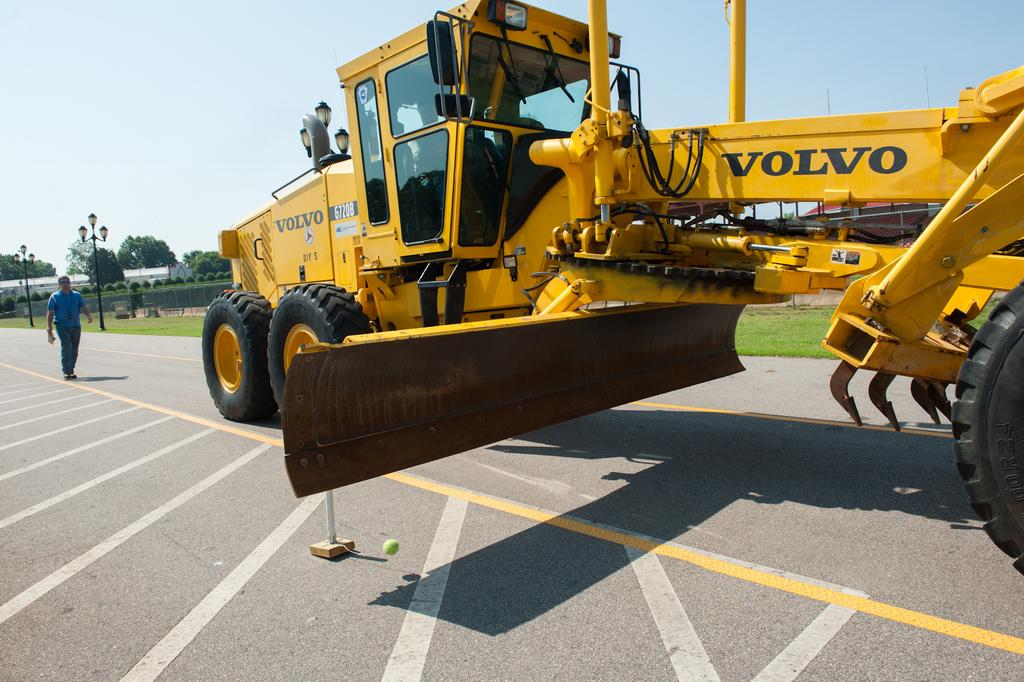<image>
Provide a brief description of the given image. Yellow Volvo tractor parked outdoors with a man walking towards it. 